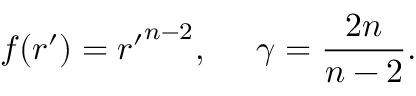<formula> <loc_0><loc_0><loc_500><loc_500>f ( r ^ { \prime } ) = { r ^ { \prime } } ^ { n - 2 } , \, \gamma = { \frac { 2 n } { n - 2 } } .</formula> 